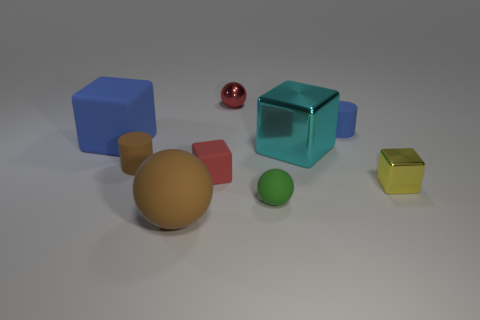Are the large brown object and the tiny blue cylinder made of the same material?
Make the answer very short. Yes. What number of tiny objects are brown cylinders or green matte things?
Your answer should be very brief. 2. Is there anything else that has the same shape as the red rubber thing?
Provide a succinct answer. Yes. Is there anything else that is the same size as the green sphere?
Offer a very short reply. Yes. There is another tiny block that is made of the same material as the cyan block; what is its color?
Offer a very short reply. Yellow. There is a rubber sphere behind the big rubber ball; what color is it?
Keep it short and to the point. Green. How many small metallic things are the same color as the tiny shiny block?
Give a very brief answer. 0. Is the number of cyan metallic blocks that are behind the small yellow shiny block less than the number of rubber balls that are behind the big rubber ball?
Provide a succinct answer. No. What number of tiny blue matte things are in front of the tiny yellow object?
Ensure brevity in your answer.  0. Are there any blue blocks that have the same material as the big cyan block?
Make the answer very short. No. 